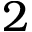Convert formula to latex. <formula><loc_0><loc_0><loc_500><loc_500>2</formula> 